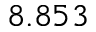Convert formula to latex. <formula><loc_0><loc_0><loc_500><loc_500>8 . 8 5 3</formula> 